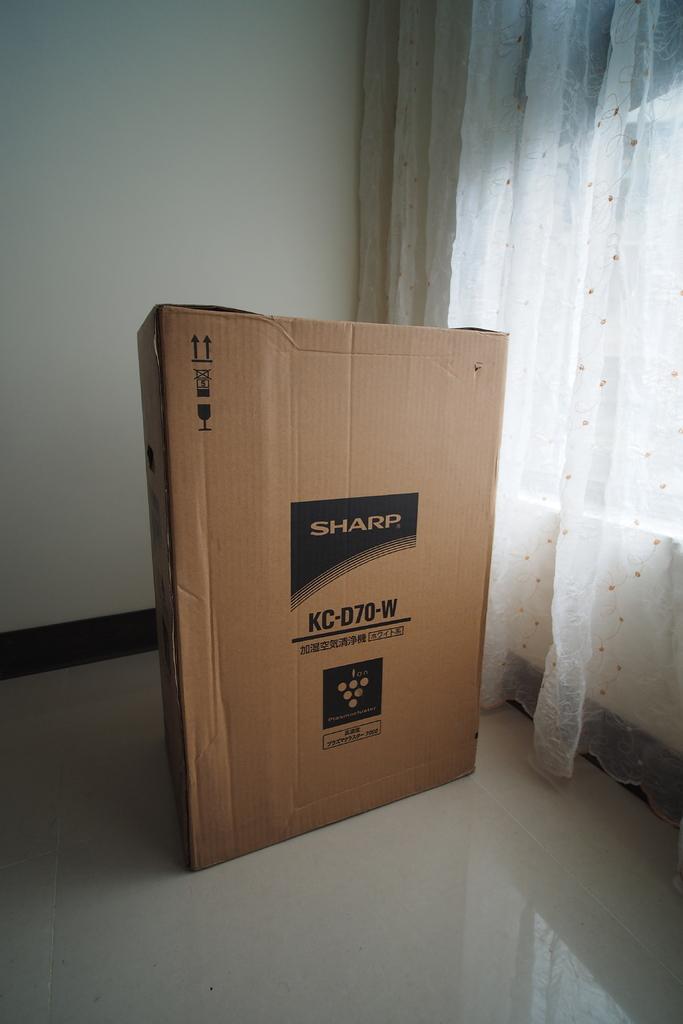What is the brand of the electronic device in the box?
Provide a succinct answer. Sharp. Is this a sharp flat screen tv?
Your response must be concise. Yes. 